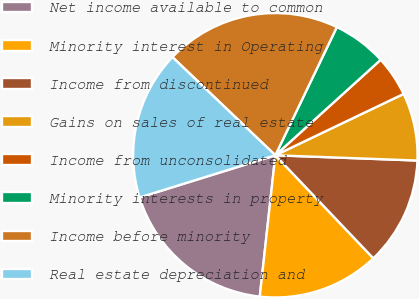<chart> <loc_0><loc_0><loc_500><loc_500><pie_chart><fcel>Net income available to common<fcel>Minority interest in Operating<fcel>Income from discontinued<fcel>Gains on sales of real estate<fcel>Income from unconsolidated<fcel>Minority interests in property<fcel>Income before minority<fcel>Real estate depreciation and<nl><fcel>18.46%<fcel>13.85%<fcel>12.31%<fcel>7.69%<fcel>4.62%<fcel>6.16%<fcel>20.0%<fcel>16.92%<nl></chart> 